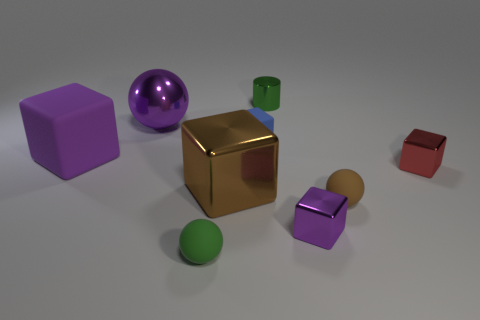Subtract all small spheres. How many spheres are left? 1 Subtract all blue blocks. How many blocks are left? 4 Subtract all red blocks. How many green balls are left? 1 Subtract all cubes. How many objects are left? 4 Subtract 0 yellow balls. How many objects are left? 9 Subtract 1 cubes. How many cubes are left? 4 Subtract all gray cubes. Subtract all blue cylinders. How many cubes are left? 5 Subtract all large red cylinders. Subtract all small brown things. How many objects are left? 8 Add 1 large blocks. How many large blocks are left? 3 Add 5 tiny red cubes. How many tiny red cubes exist? 6 